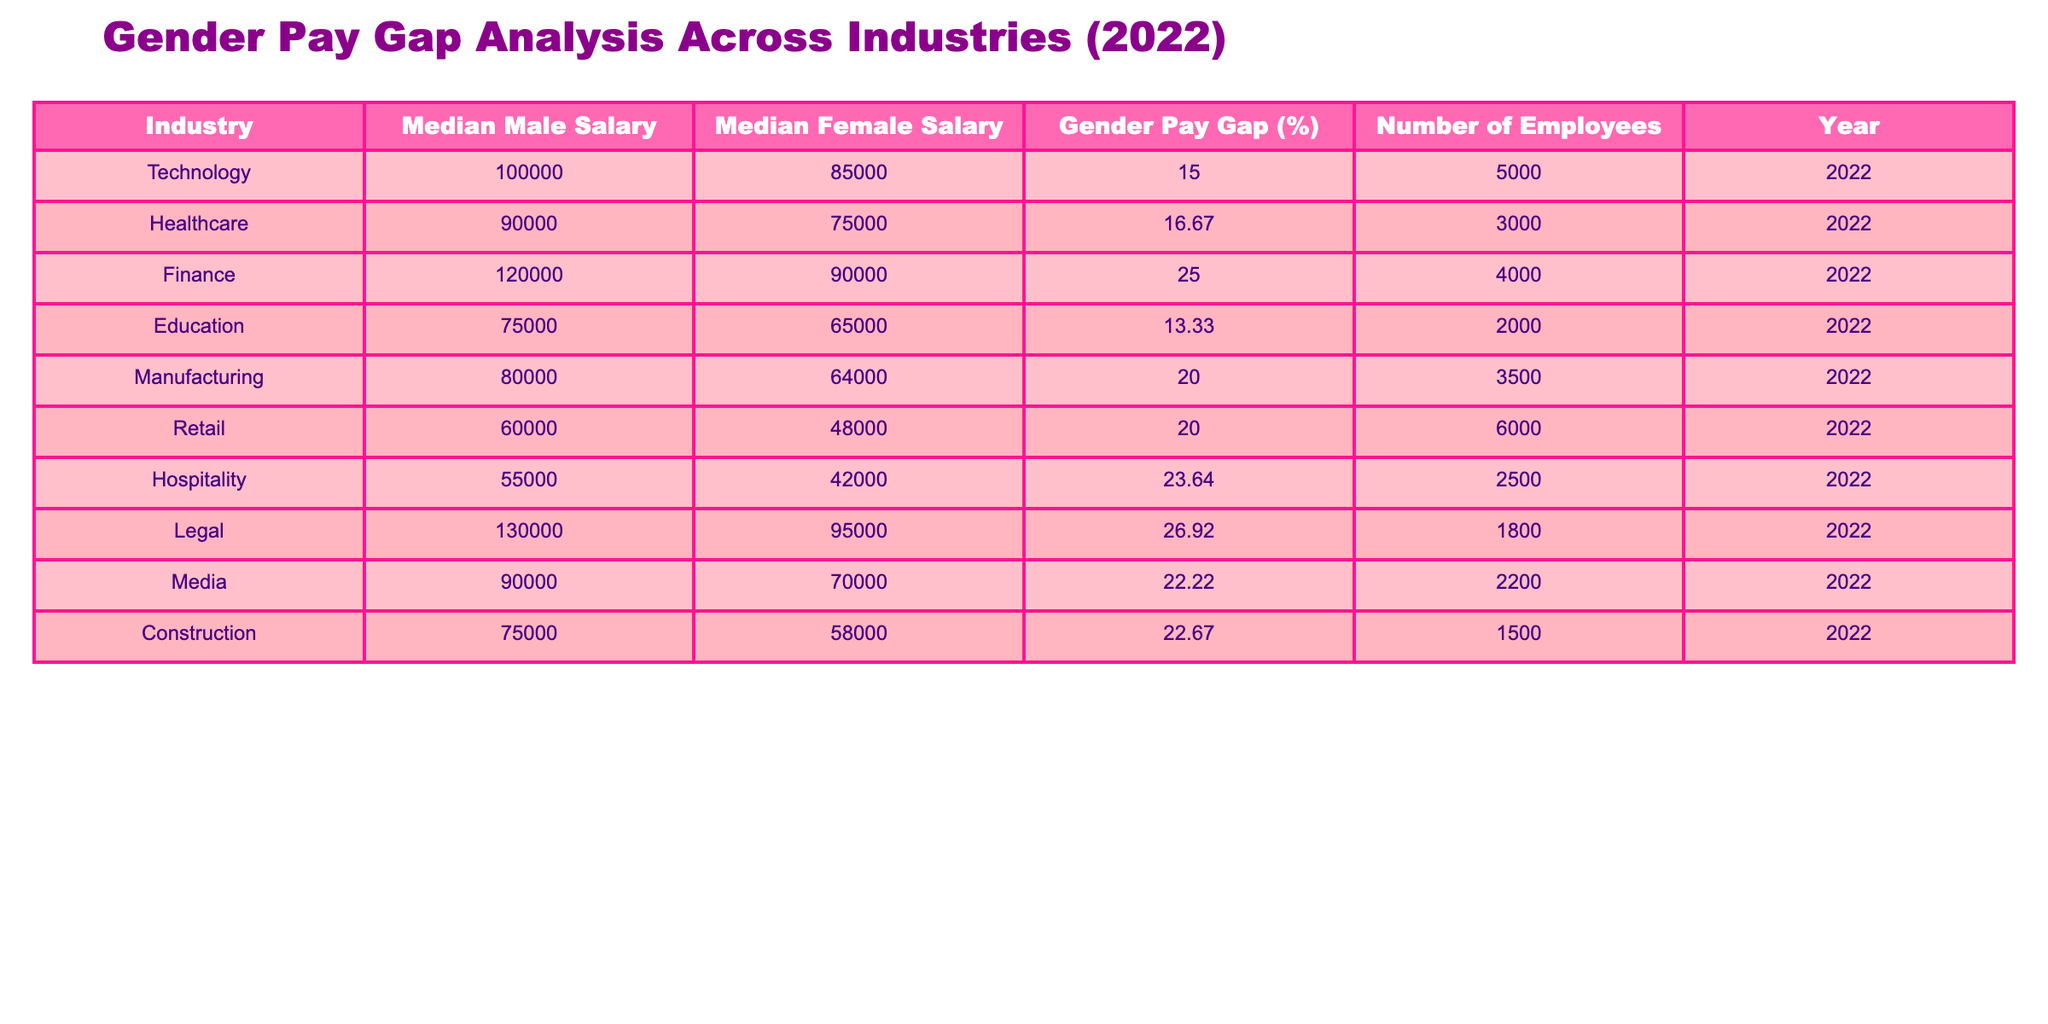What is the median salary for females in the Finance industry? The table shows the median female salary under the Finance industry as $90,000.
Answer: $90,000 Which industry has the highest gender pay gap? The Finance industry has the highest gender pay gap of 25%.
Answer: 25% Is the median male salary in Media greater than in Retail? According to the table, the median male salary in Media is $90,000, while in Retail, it is $60,000. Therefore, yes, Media has a greater median male salary than Retail.
Answer: Yes What is the average gender pay gap across all listed industries? To find the average gender pay gap, sum the gender pay gaps: 15 + 16.67 + 25 + 13.33 + 20 + 20 + 23.64 + 26.92 + 22.22 + 22.67 =  204.45. There are 10 industries, so the average is 204.45 / 10 = 20.445%.
Answer: 20.45% Does the Healthcare industry have a larger gender pay gap than Education? The Healthcare industry has a gender pay gap of 16.67% while Education has a gap of 13.33%. Hence, yes, Healthcare has a larger gender pay gap than Education.
Answer: Yes What is the difference in the median salaries of males and females in the Hospitality industry? For the Hospitality industry, the median male salary is $55,000 and the median female salary is $42,000. The difference is $55,000 - $42,000 = $13,000.
Answer: $13,000 Which industries have a median female salary below $70,000? The industries with a median female salary below $70,000 are Healthcare ($75,000), Manufacturing ($64,000), Retail ($48,000), and Hospitality ($42,000).
Answer: Healthcare, Manufacturing, Retail, Hospitality What portion of employees in the Construction industry earns a female salary? Construction has a total of 1,500 employees, with females earning a median salary of $58,000. To determine the proportion of female employees, we do not directly have that from the table, thus we cannot answer this accurately.
Answer: Not directly answerable Which industry has a median male salary that is closest to $80,000? The median male salary closest to $80,000 is in the Manufacturing industry, which is $80,000.
Answer: Manufacturing 